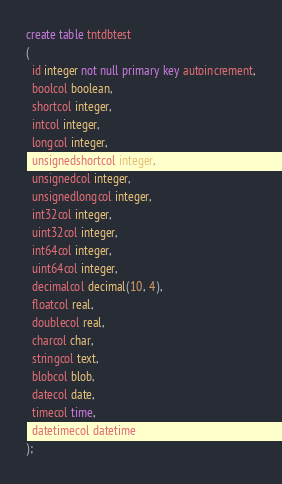Convert code to text. <code><loc_0><loc_0><loc_500><loc_500><_SQL_>create table tntdbtest
(
  id integer not null primary key autoincrement,
  boolcol boolean,
  shortcol integer,
  intcol integer,
  longcol integer,
  unsignedshortcol integer,
  unsignedcol integer,
  unsignedlongcol integer,
  int32col integer,
  uint32col integer,
  int64col integer,
  uint64col integer,
  decimalcol decimal(10, 4),
  floatcol real,
  doublecol real,
  charcol char,
  stringcol text,
  blobcol blob,
  datecol date,
  timecol time,
  datetimecol datetime
);
</code> 